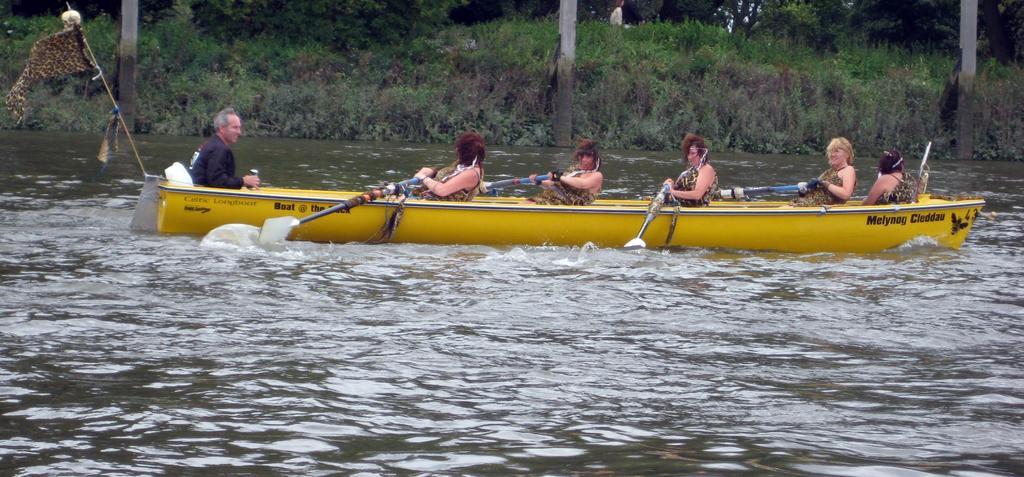Can you describe this image briefly? In this image we can see a yellow color boat which is floating on the water in which people are sitting and holding paddles in their hands. In the background, we can see grass and sticks. 